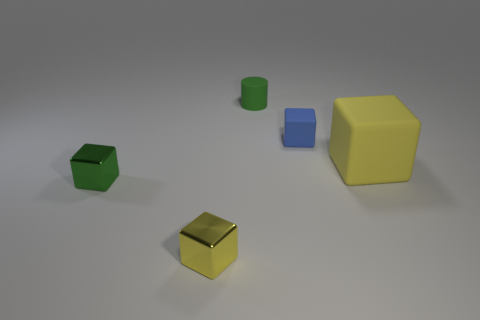There is a shiny object to the left of the yellow metal block; is it the same size as the green cylinder?
Ensure brevity in your answer.  Yes. There is a thing that is behind the large matte thing and to the left of the blue object; what color is it?
Keep it short and to the point. Green. What is the shape of the yellow thing that is the same size as the green metallic thing?
Provide a short and direct response. Cube. Are there any large matte objects of the same color as the tiny matte cylinder?
Provide a short and direct response. No. Are there the same number of small cylinders that are right of the tiny green matte cylinder and blocks?
Ensure brevity in your answer.  No. Does the big block have the same color as the cylinder?
Offer a very short reply. No. What size is the cube that is both on the right side of the green shiny block and to the left of the cylinder?
Offer a terse response. Small. What is the color of the tiny cylinder that is the same material as the blue cube?
Your answer should be compact. Green. How many big things are made of the same material as the blue block?
Offer a terse response. 1. Are there an equal number of metal objects that are to the left of the tiny yellow shiny cube and blue rubber cubes that are behind the green rubber thing?
Provide a succinct answer. No. 